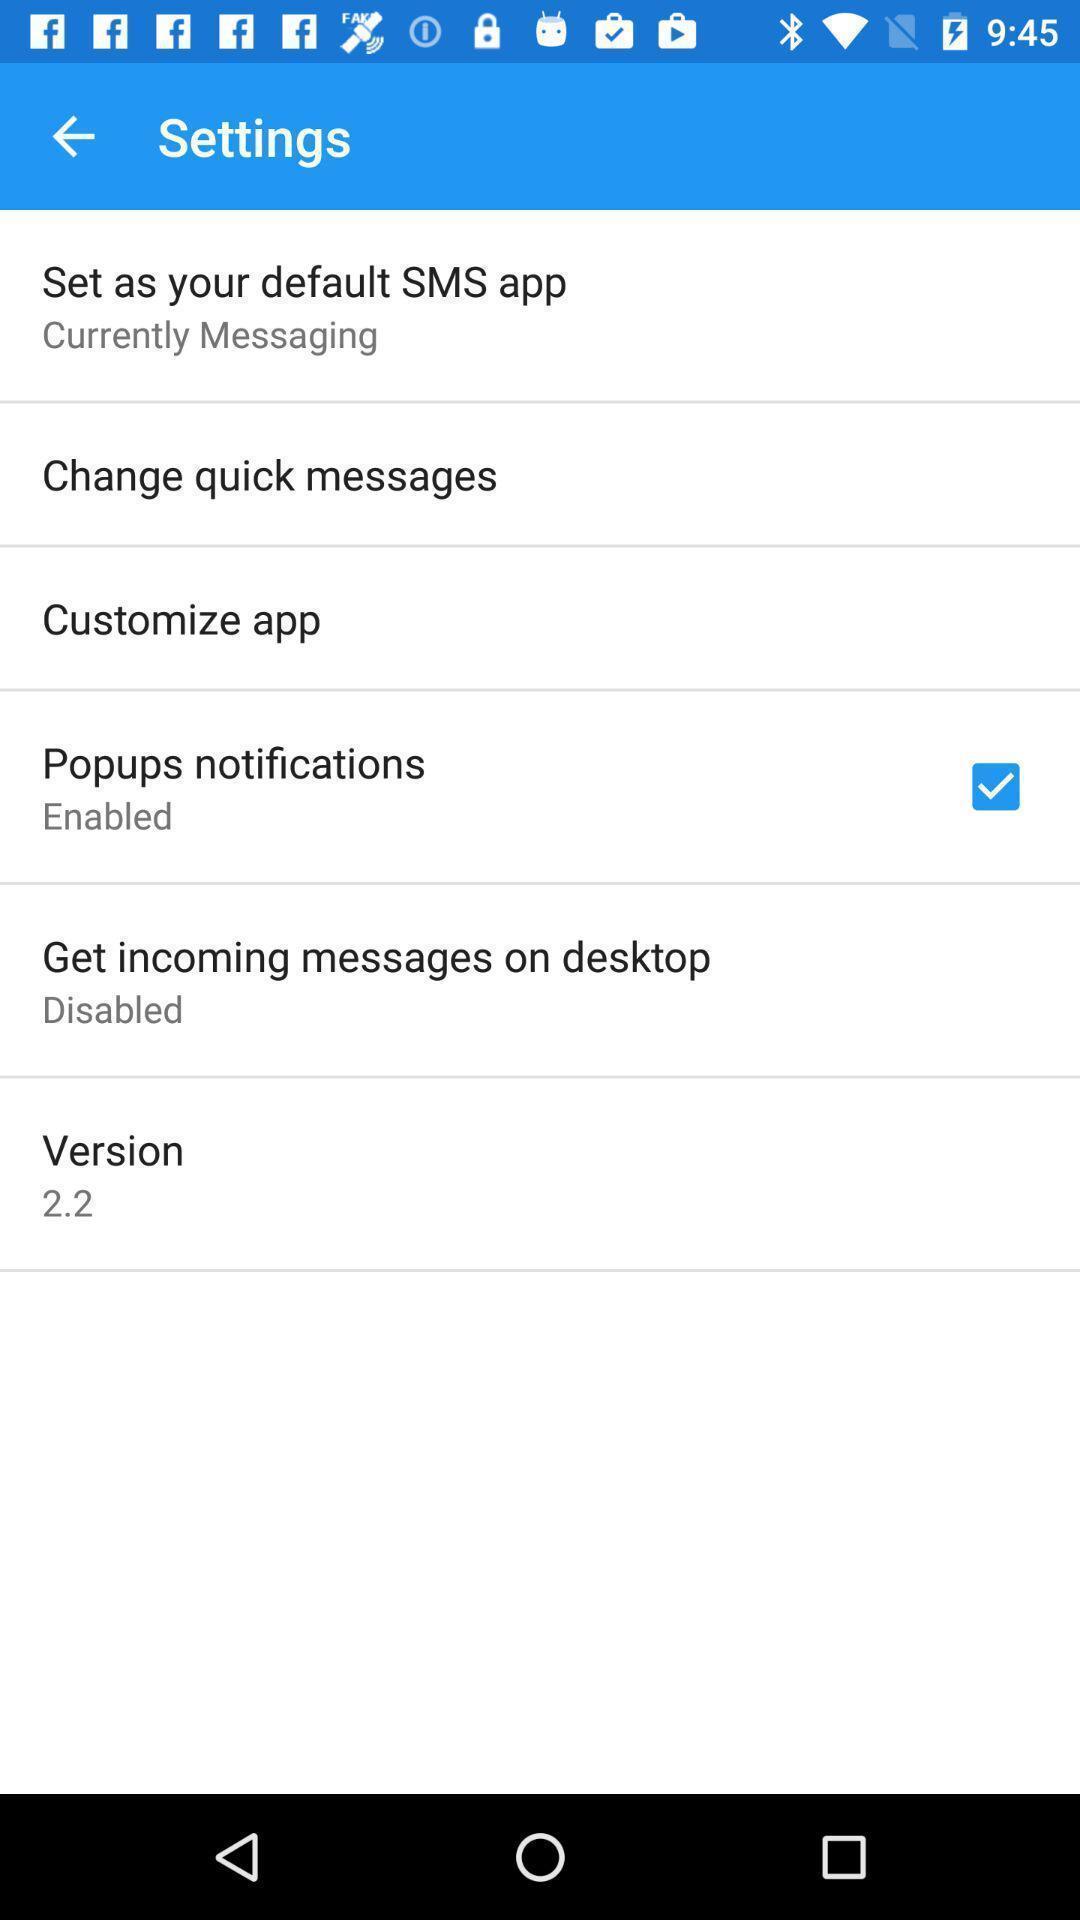Describe this image in words. Settings page displayed. 